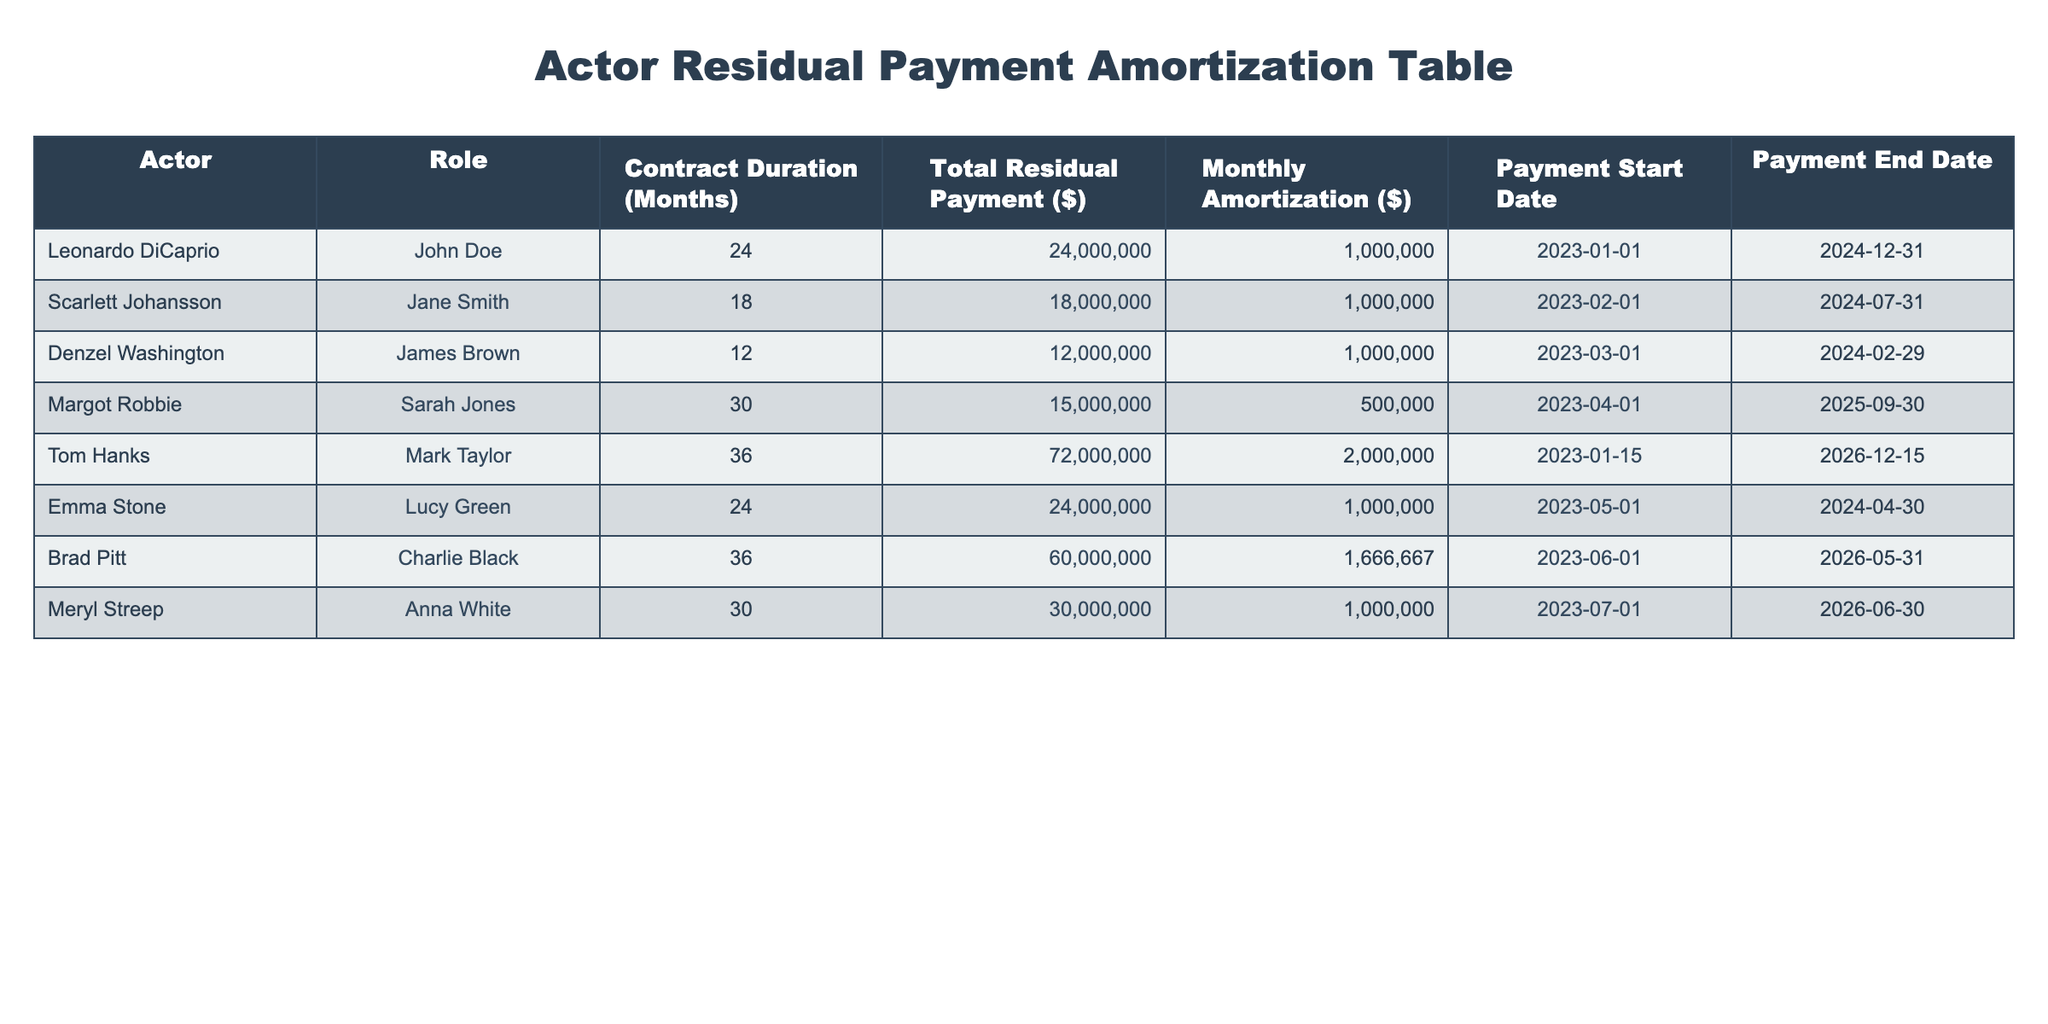What is the total residual payment for Leonardo DiCaprio? The table states that Leonardo DiCaprio has a total residual payment of $24,000,000.
Answer: 24,000,000 How many months is Emma Stone's contract duration? According to the table, Emma Stone's contract duration is 24 months.
Answer: 24 months What is the difference in total residual payments between Tom Hanks and Margot Robbie? Tom Hanks has a total residual payment of $72,000,000 and Margot Robbie has a total residual payment of $15,000,000. The difference is $72,000,000 - $15,000,000 = $57,000,000.
Answer: 57,000,000 Is Denzel Washington's monthly amortization the same as Scarlett Johansson's? Both Denzel Washington and Scarlett Johansson have a monthly amortization of $1,000,000. Therefore, the answer is yes, their monthly amortizations are the same.
Answer: Yes What is the average monthly amortization for all actors in the table? To find the average, sum all monthly amortizations: 1,000,000 (Leonardo) + 1,000,000 (Scarlett) + 1,000,000 (Denzel) + 500,000 (Margot) + 2,000,000 (Tom) + 1,000,000 (Emma) + 1,666,667 (Brad) + 1,000,000 (Meryl) = 8,166,667. There are 8 actors, so the average is 8,166,667 / 8 = 1,020,833.375.
Answer: 1,020,833.38 What is the total duration of contracts that are longer than 24 months? The actors with contracts longer than 24 months are Tom Hanks (36 months) and Brad Pitt (36 months). So, total duration = 36 + 36 = 72 months.
Answer: 72 months 